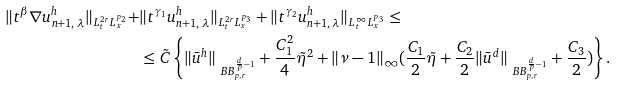Convert formula to latex. <formula><loc_0><loc_0><loc_500><loc_500>\| t ^ { \beta } \nabla u ^ { h } _ { n + 1 , \, \lambda } \| _ { L ^ { 2 r } _ { t } L ^ { p _ { 2 } } _ { x } } + & \| t ^ { \gamma _ { 1 } } u ^ { h } _ { n + 1 , \, \lambda } \| _ { L ^ { 2 r } _ { t } L ^ { p _ { 3 } } _ { x } } + \| t ^ { \gamma _ { 2 } } u ^ { h } _ { n + 1 , \, \lambda } \| _ { L ^ { \infty } _ { t } L ^ { p _ { 3 } } _ { x } } \leq \\ & \leq \tilde { C } \left \{ \| \bar { u } ^ { h } \| _ { \ B B _ { p , r } ^ { \frac { d } { p } - 1 } } + \frac { C _ { 1 } ^ { 2 } } { 4 } \tilde { \eta } ^ { 2 } + \| \nu - 1 \| _ { \infty } ( \frac { C _ { 1 } } { 2 } \tilde { \eta } + \frac { C _ { 2 } } { 2 } \| \bar { u } ^ { d } \| _ { \ B B _ { p , r } ^ { \frac { d } { p } - 1 } } + \frac { C _ { 3 } } { 2 } ) \right \} .</formula> 